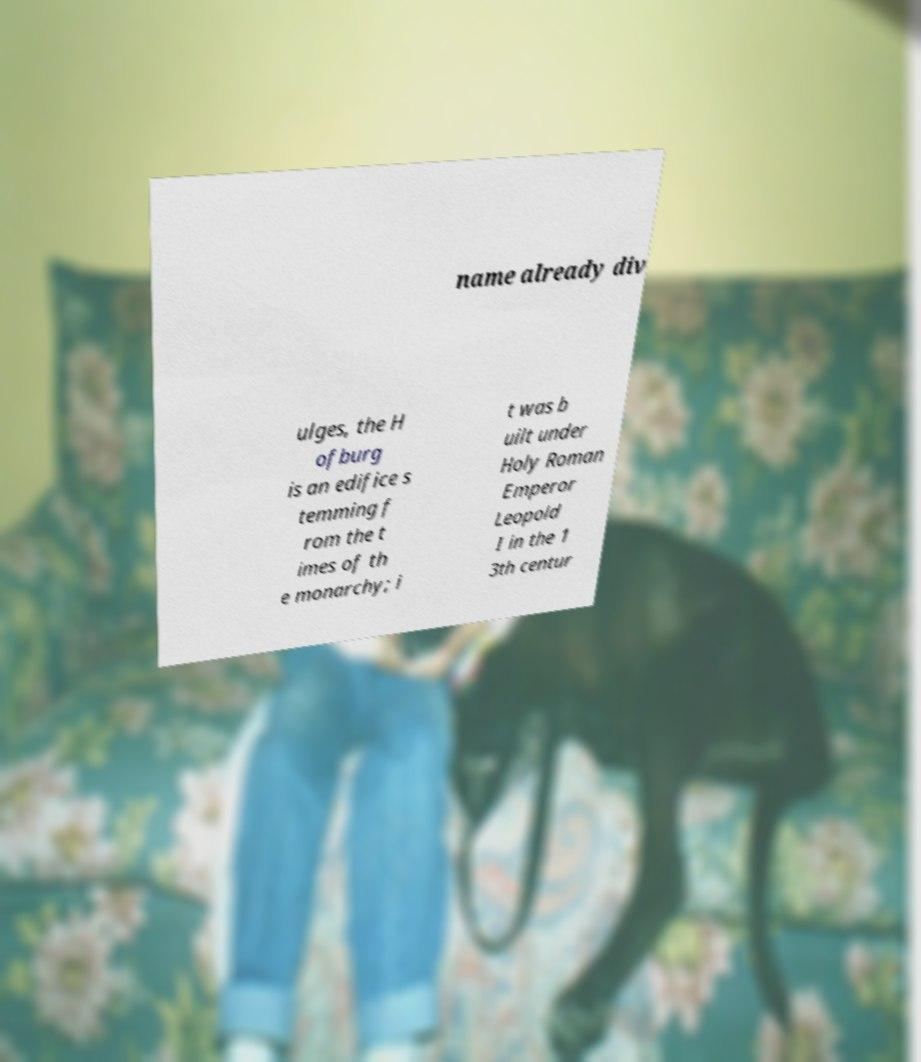Please read and relay the text visible in this image. What does it say? name already div ulges, the H ofburg is an edifice s temming f rom the t imes of th e monarchy; i t was b uilt under Holy Roman Emperor Leopold I in the 1 3th centur 